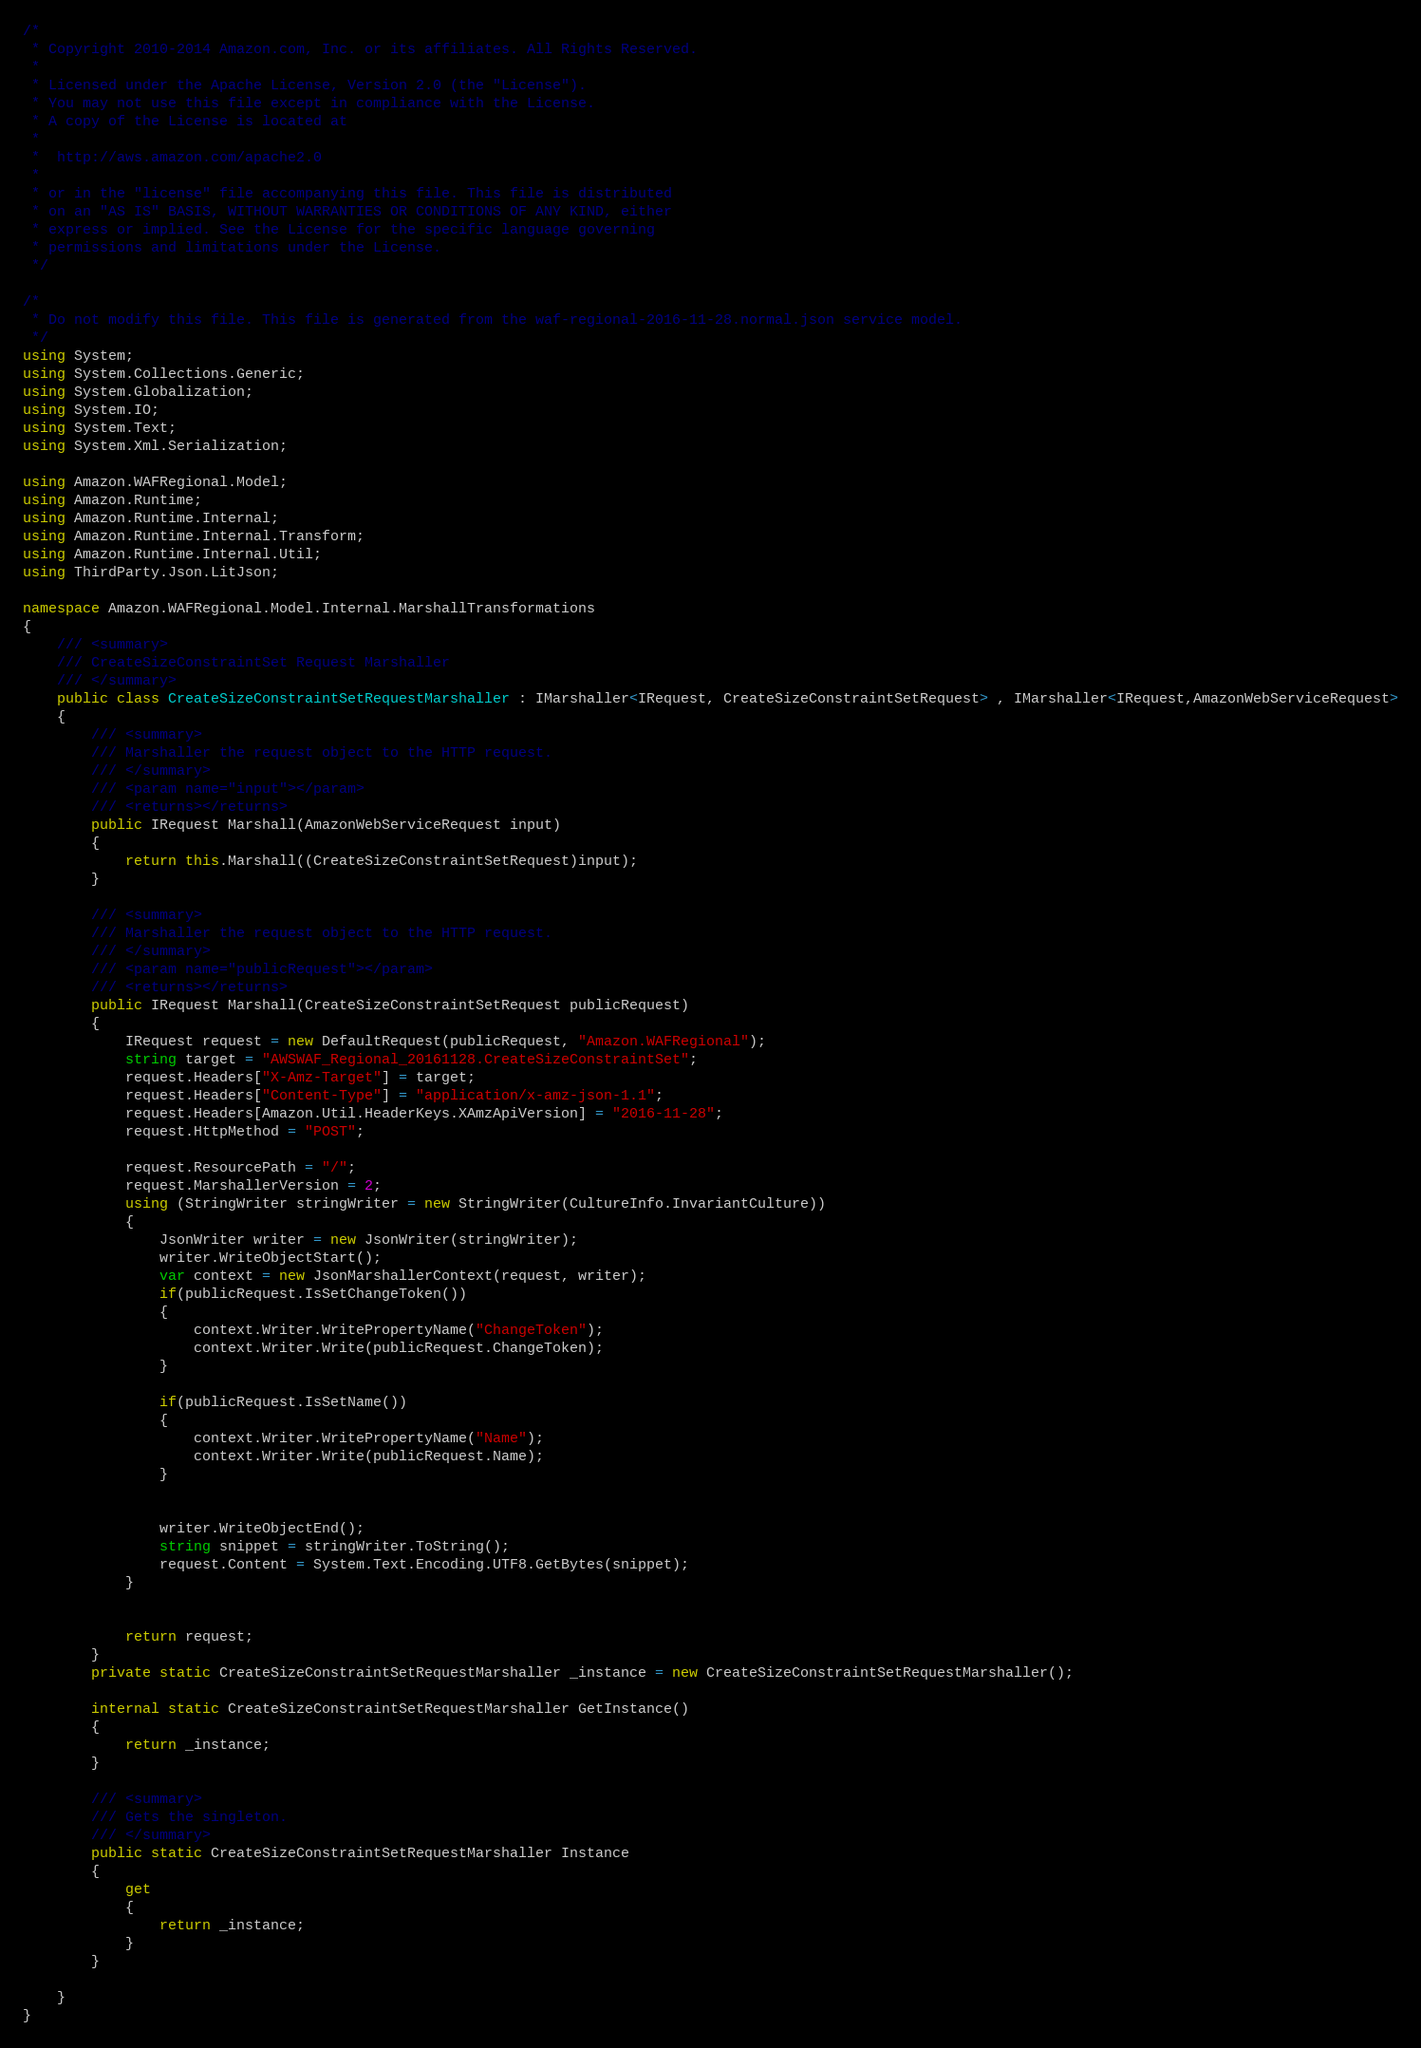Convert code to text. <code><loc_0><loc_0><loc_500><loc_500><_C#_>/*
 * Copyright 2010-2014 Amazon.com, Inc. or its affiliates. All Rights Reserved.
 * 
 * Licensed under the Apache License, Version 2.0 (the "License").
 * You may not use this file except in compliance with the License.
 * A copy of the License is located at
 * 
 *  http://aws.amazon.com/apache2.0
 * 
 * or in the "license" file accompanying this file. This file is distributed
 * on an "AS IS" BASIS, WITHOUT WARRANTIES OR CONDITIONS OF ANY KIND, either
 * express or implied. See the License for the specific language governing
 * permissions and limitations under the License.
 */

/*
 * Do not modify this file. This file is generated from the waf-regional-2016-11-28.normal.json service model.
 */
using System;
using System.Collections.Generic;
using System.Globalization;
using System.IO;
using System.Text;
using System.Xml.Serialization;

using Amazon.WAFRegional.Model;
using Amazon.Runtime;
using Amazon.Runtime.Internal;
using Amazon.Runtime.Internal.Transform;
using Amazon.Runtime.Internal.Util;
using ThirdParty.Json.LitJson;

namespace Amazon.WAFRegional.Model.Internal.MarshallTransformations
{
    /// <summary>
    /// CreateSizeConstraintSet Request Marshaller
    /// </summary>       
    public class CreateSizeConstraintSetRequestMarshaller : IMarshaller<IRequest, CreateSizeConstraintSetRequest> , IMarshaller<IRequest,AmazonWebServiceRequest>
    {
        /// <summary>
        /// Marshaller the request object to the HTTP request.
        /// </summary>  
        /// <param name="input"></param>
        /// <returns></returns>
        public IRequest Marshall(AmazonWebServiceRequest input)
        {
            return this.Marshall((CreateSizeConstraintSetRequest)input);
        }

        /// <summary>
        /// Marshaller the request object to the HTTP request.
        /// </summary>  
        /// <param name="publicRequest"></param>
        /// <returns></returns>
        public IRequest Marshall(CreateSizeConstraintSetRequest publicRequest)
        {
            IRequest request = new DefaultRequest(publicRequest, "Amazon.WAFRegional");
            string target = "AWSWAF_Regional_20161128.CreateSizeConstraintSet";
            request.Headers["X-Amz-Target"] = target;
            request.Headers["Content-Type"] = "application/x-amz-json-1.1";
            request.Headers[Amazon.Util.HeaderKeys.XAmzApiVersion] = "2016-11-28";            
            request.HttpMethod = "POST";

            request.ResourcePath = "/";
            request.MarshallerVersion = 2;
            using (StringWriter stringWriter = new StringWriter(CultureInfo.InvariantCulture))
            {
                JsonWriter writer = new JsonWriter(stringWriter);
                writer.WriteObjectStart();
                var context = new JsonMarshallerContext(request, writer);
                if(publicRequest.IsSetChangeToken())
                {
                    context.Writer.WritePropertyName("ChangeToken");
                    context.Writer.Write(publicRequest.ChangeToken);
                }

                if(publicRequest.IsSetName())
                {
                    context.Writer.WritePropertyName("Name");
                    context.Writer.Write(publicRequest.Name);
                }

        
                writer.WriteObjectEnd();
                string snippet = stringWriter.ToString();
                request.Content = System.Text.Encoding.UTF8.GetBytes(snippet);
            }


            return request;
        }
        private static CreateSizeConstraintSetRequestMarshaller _instance = new CreateSizeConstraintSetRequestMarshaller();        

        internal static CreateSizeConstraintSetRequestMarshaller GetInstance()
        {
            return _instance;
        }

        /// <summary>
        /// Gets the singleton.
        /// </summary>  
        public static CreateSizeConstraintSetRequestMarshaller Instance
        {
            get
            {
                return _instance;
            }
        }

    }
}</code> 